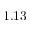<formula> <loc_0><loc_0><loc_500><loc_500>1 . 1 3</formula> 